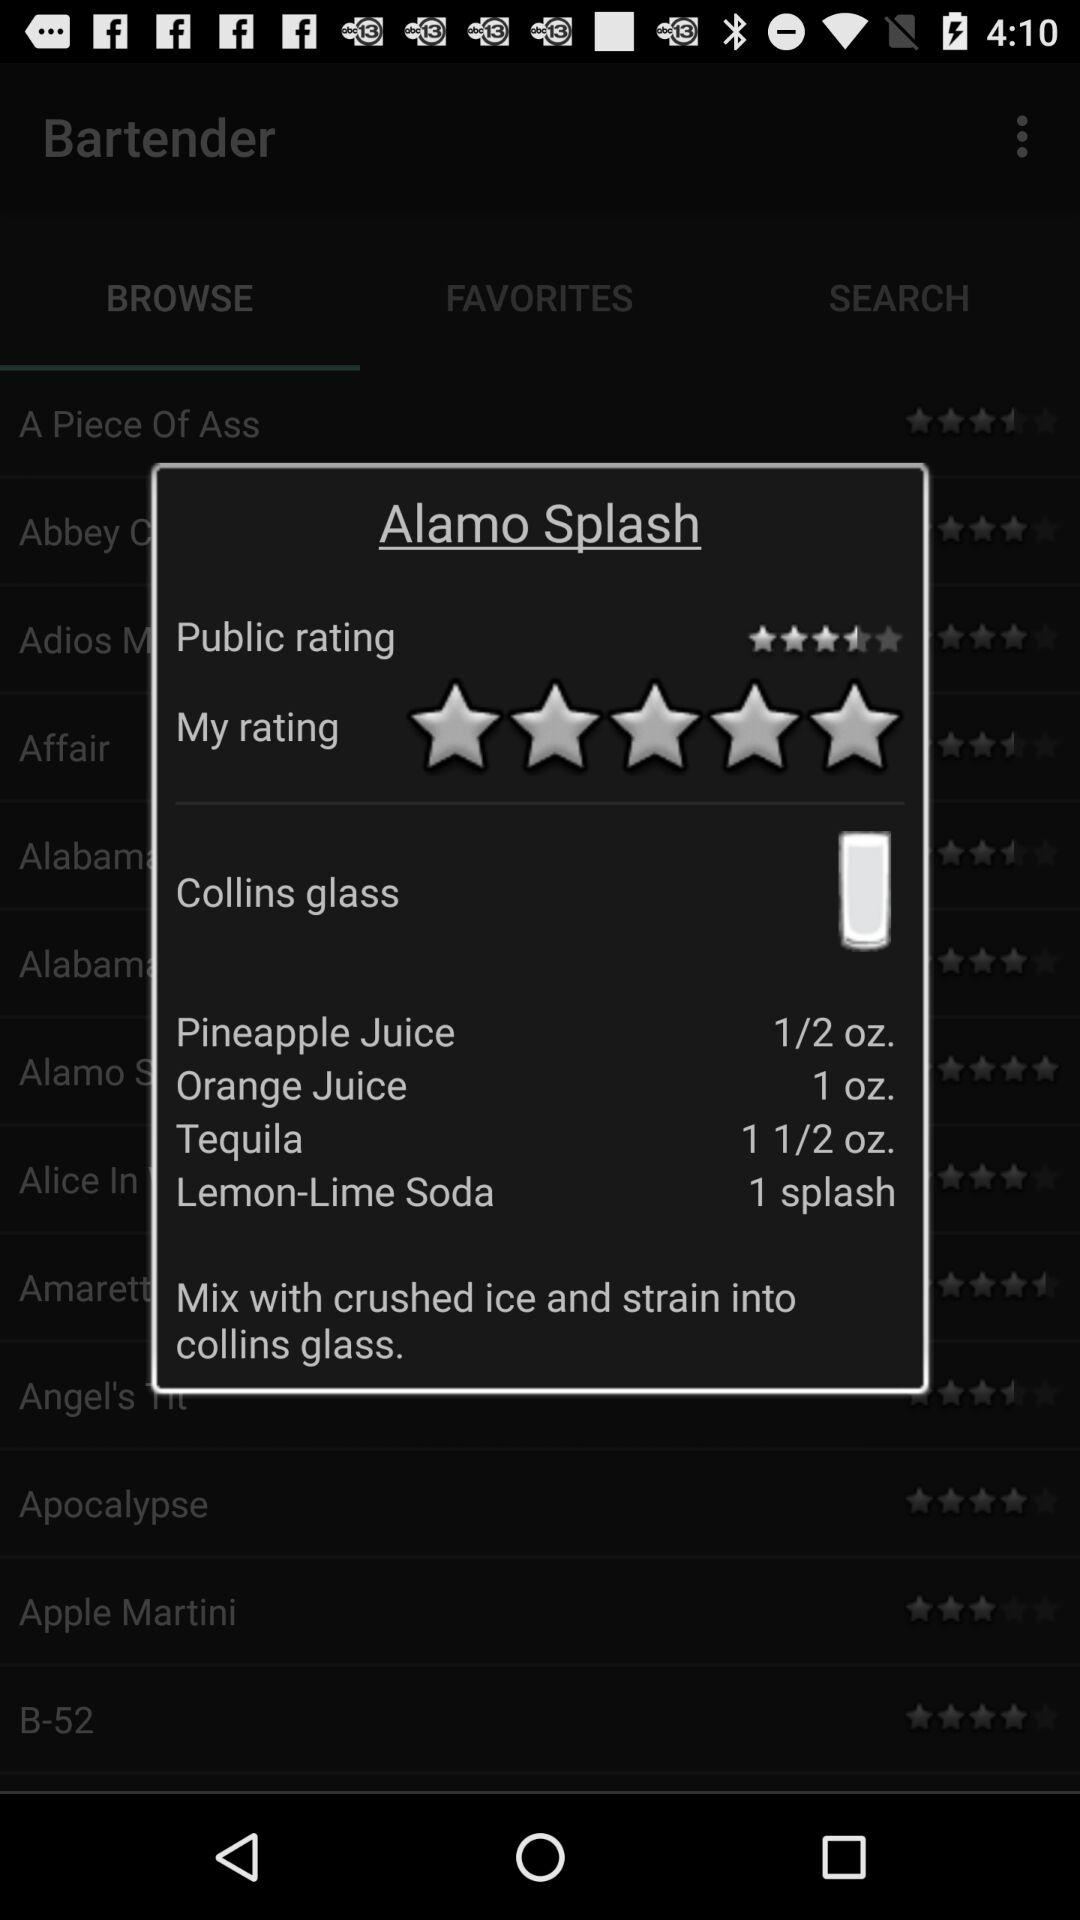What is "My rating"? "My rating" is 5 stars. 